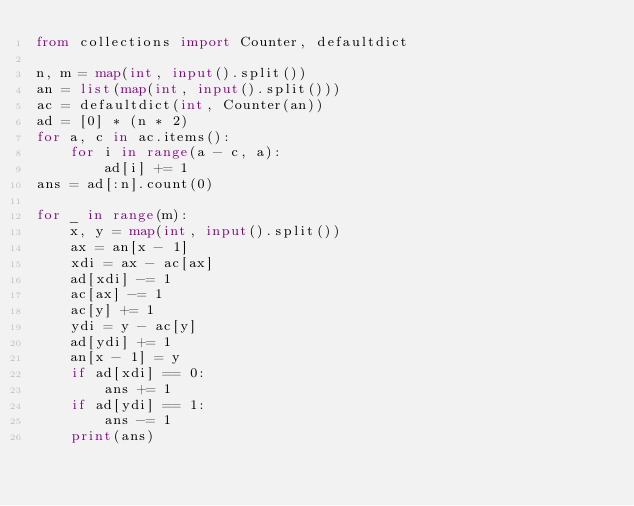Convert code to text. <code><loc_0><loc_0><loc_500><loc_500><_Python_>from collections import Counter, defaultdict

n, m = map(int, input().split())
an = list(map(int, input().split()))
ac = defaultdict(int, Counter(an))
ad = [0] * (n * 2)
for a, c in ac.items():
    for i in range(a - c, a):
        ad[i] += 1
ans = ad[:n].count(0)

for _ in range(m):
    x, y = map(int, input().split())
    ax = an[x - 1]
    xdi = ax - ac[ax]
    ad[xdi] -= 1
    ac[ax] -= 1
    ac[y] += 1
    ydi = y - ac[y]
    ad[ydi] += 1
    an[x - 1] = y
    if ad[xdi] == 0:
        ans += 1
    if ad[ydi] == 1:
        ans -= 1
    print(ans)
</code> 